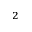Convert formula to latex. <formula><loc_0><loc_0><loc_500><loc_500>^ { 2 }</formula> 